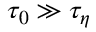<formula> <loc_0><loc_0><loc_500><loc_500>\tau _ { 0 } \gg \tau _ { \eta }</formula> 